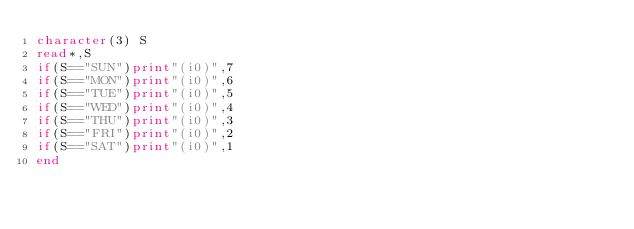Convert code to text. <code><loc_0><loc_0><loc_500><loc_500><_FORTRAN_>character(3) S
read*,S
if(S=="SUN")print"(i0)",7
if(S=="MON")print"(i0)",6
if(S=="TUE")print"(i0)",5
if(S=="WED")print"(i0)",4
if(S=="THU")print"(i0)",3
if(S=="FRI")print"(i0)",2
if(S=="SAT")print"(i0)",1
end</code> 